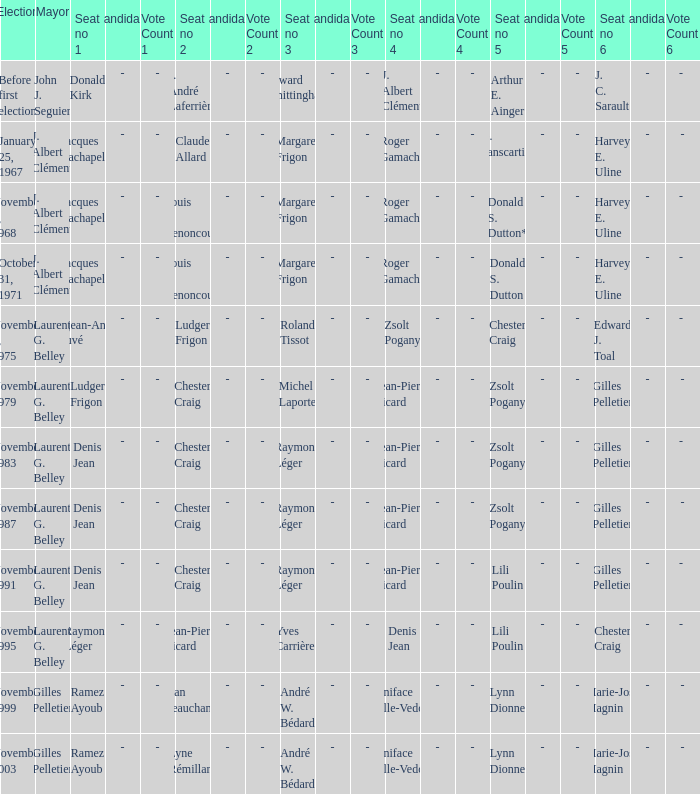Who is seat no 1 when the mayor was john j. seguier Donald Kirk. 